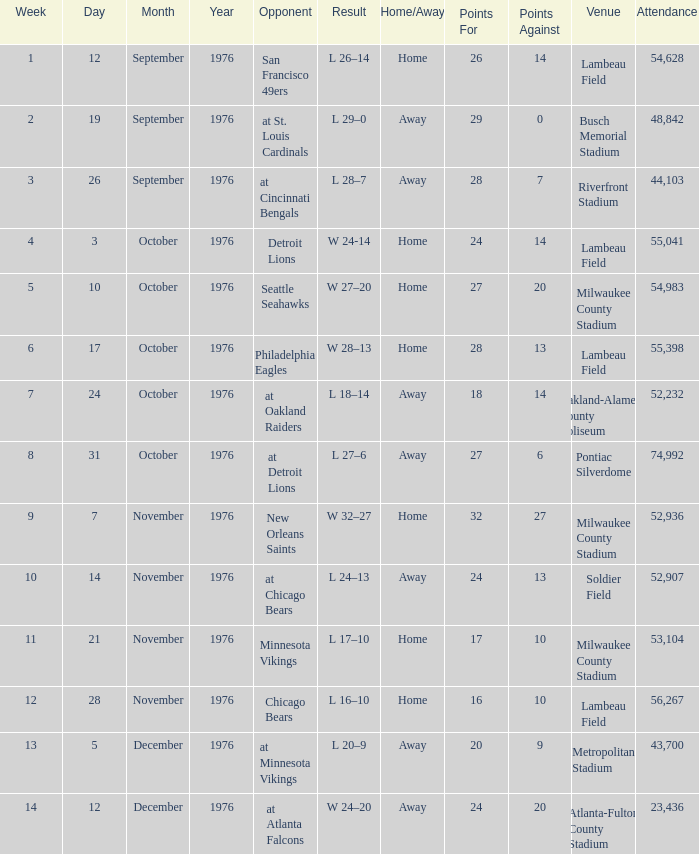What is the lowest week number where they played against the Detroit Lions? 4.0. 